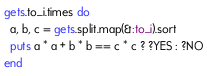Convert code to text. <code><loc_0><loc_0><loc_500><loc_500><_Ruby_>gets.to_i.times do
  a, b, c = gets.split.map(&:to_i).sort
  puts a * a + b * b == c * c ? ?YES : ?NO
end</code> 